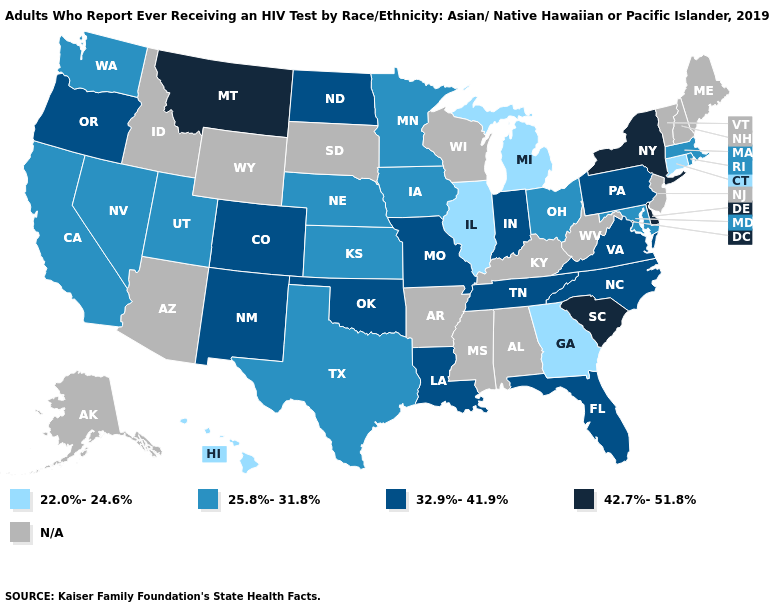Which states have the highest value in the USA?
Keep it brief. Delaware, Montana, New York, South Carolina. Does Hawaii have the lowest value in the West?
Concise answer only. Yes. Name the states that have a value in the range 22.0%-24.6%?
Be succinct. Connecticut, Georgia, Hawaii, Illinois, Michigan. Name the states that have a value in the range 25.8%-31.8%?
Concise answer only. California, Iowa, Kansas, Maryland, Massachusetts, Minnesota, Nebraska, Nevada, Ohio, Rhode Island, Texas, Utah, Washington. Does Montana have the highest value in the USA?
Write a very short answer. Yes. Which states have the lowest value in the USA?
Answer briefly. Connecticut, Georgia, Hawaii, Illinois, Michigan. What is the lowest value in the South?
Give a very brief answer. 22.0%-24.6%. Which states have the lowest value in the MidWest?
Quick response, please. Illinois, Michigan. Name the states that have a value in the range 22.0%-24.6%?
Give a very brief answer. Connecticut, Georgia, Hawaii, Illinois, Michigan. Name the states that have a value in the range 42.7%-51.8%?
Concise answer only. Delaware, Montana, New York, South Carolina. Among the states that border Colorado , which have the highest value?
Keep it brief. New Mexico, Oklahoma. Name the states that have a value in the range N/A?
Give a very brief answer. Alabama, Alaska, Arizona, Arkansas, Idaho, Kentucky, Maine, Mississippi, New Hampshire, New Jersey, South Dakota, Vermont, West Virginia, Wisconsin, Wyoming. Among the states that border Wyoming , does Colorado have the lowest value?
Concise answer only. No. What is the value of Utah?
Short answer required. 25.8%-31.8%. 